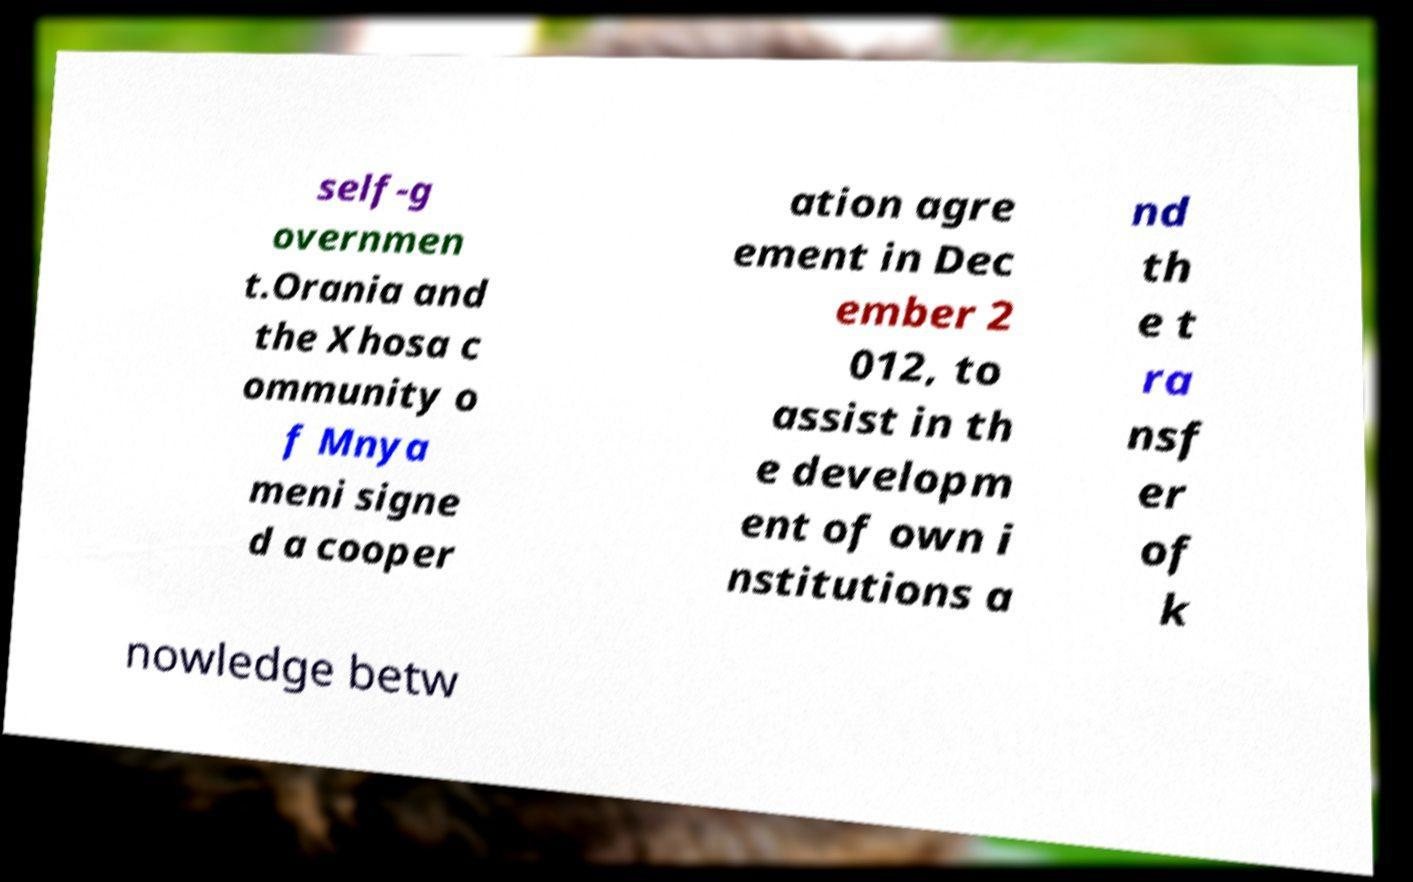There's text embedded in this image that I need extracted. Can you transcribe it verbatim? self-g overnmen t.Orania and the Xhosa c ommunity o f Mnya meni signe d a cooper ation agre ement in Dec ember 2 012, to assist in th e developm ent of own i nstitutions a nd th e t ra nsf er of k nowledge betw 